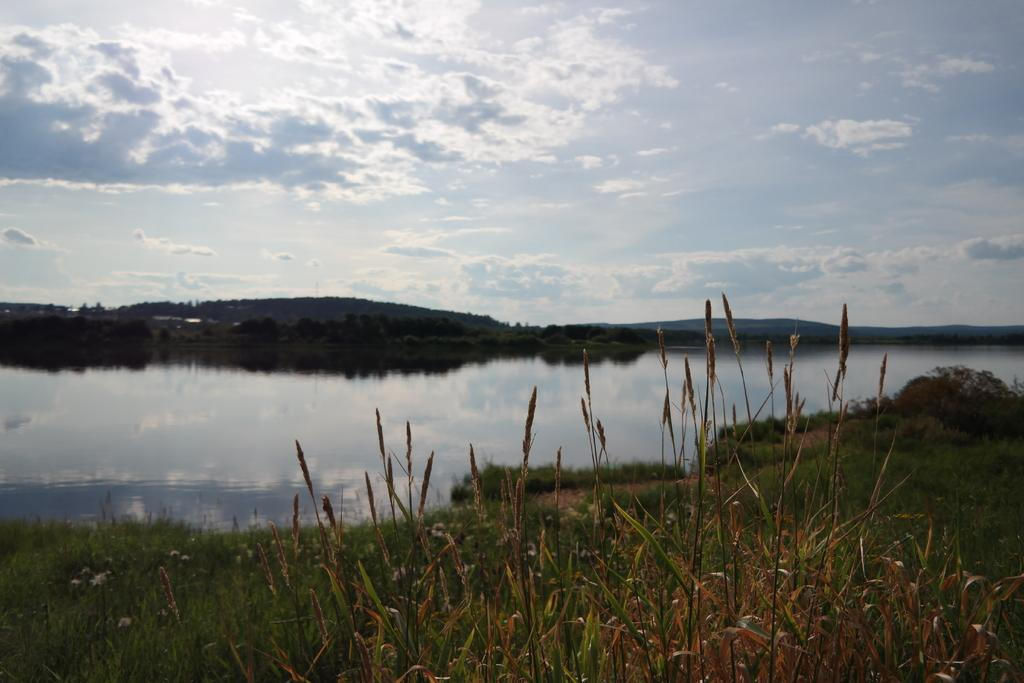What type of living organisms can be seen in the image? Plants can be seen in the image. What is the surface on which the plants are growing? There is a greenery ground in the image. What is in front of the greenery ground? There is water in front of the greenery ground. What can be seen in the background of the image? Trees and mountains are visible in the background of the image. What is the condition of the sky in the image? The sky is visible in the image and is a bit cloudy. What type of skin condition can be seen on the crow in the image? There is no crow present in the image, so it is not possible to determine if any skin condition is visible. What type of street is visible in the image? There is no street visible in the image; it features plants, greenery ground, water, trees, mountains, and a cloudy sky. 